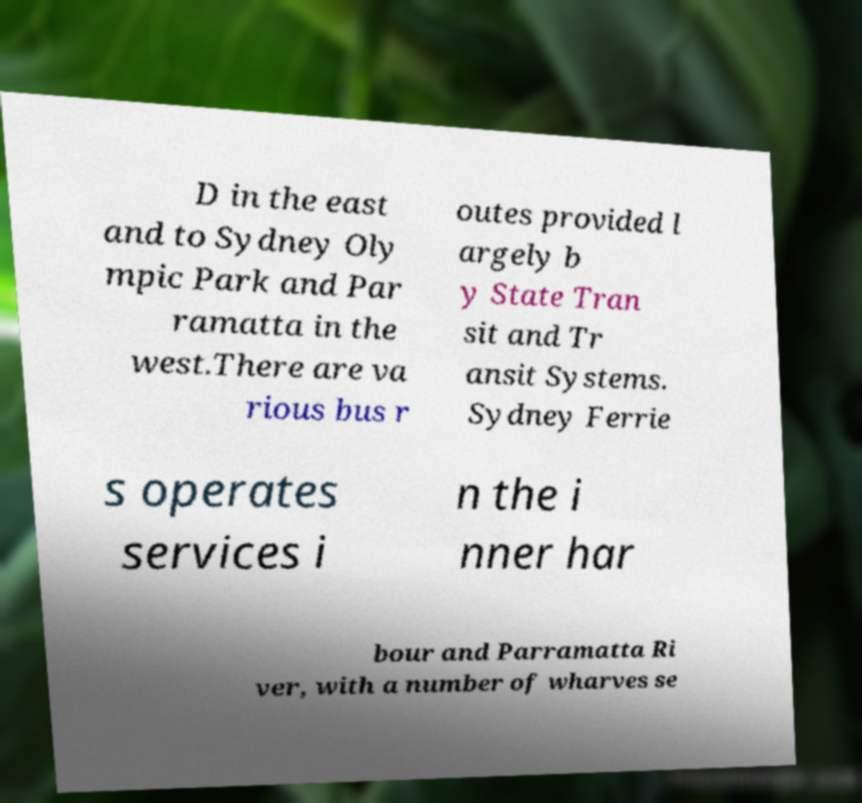For documentation purposes, I need the text within this image transcribed. Could you provide that? D in the east and to Sydney Oly mpic Park and Par ramatta in the west.There are va rious bus r outes provided l argely b y State Tran sit and Tr ansit Systems. Sydney Ferrie s operates services i n the i nner har bour and Parramatta Ri ver, with a number of wharves se 